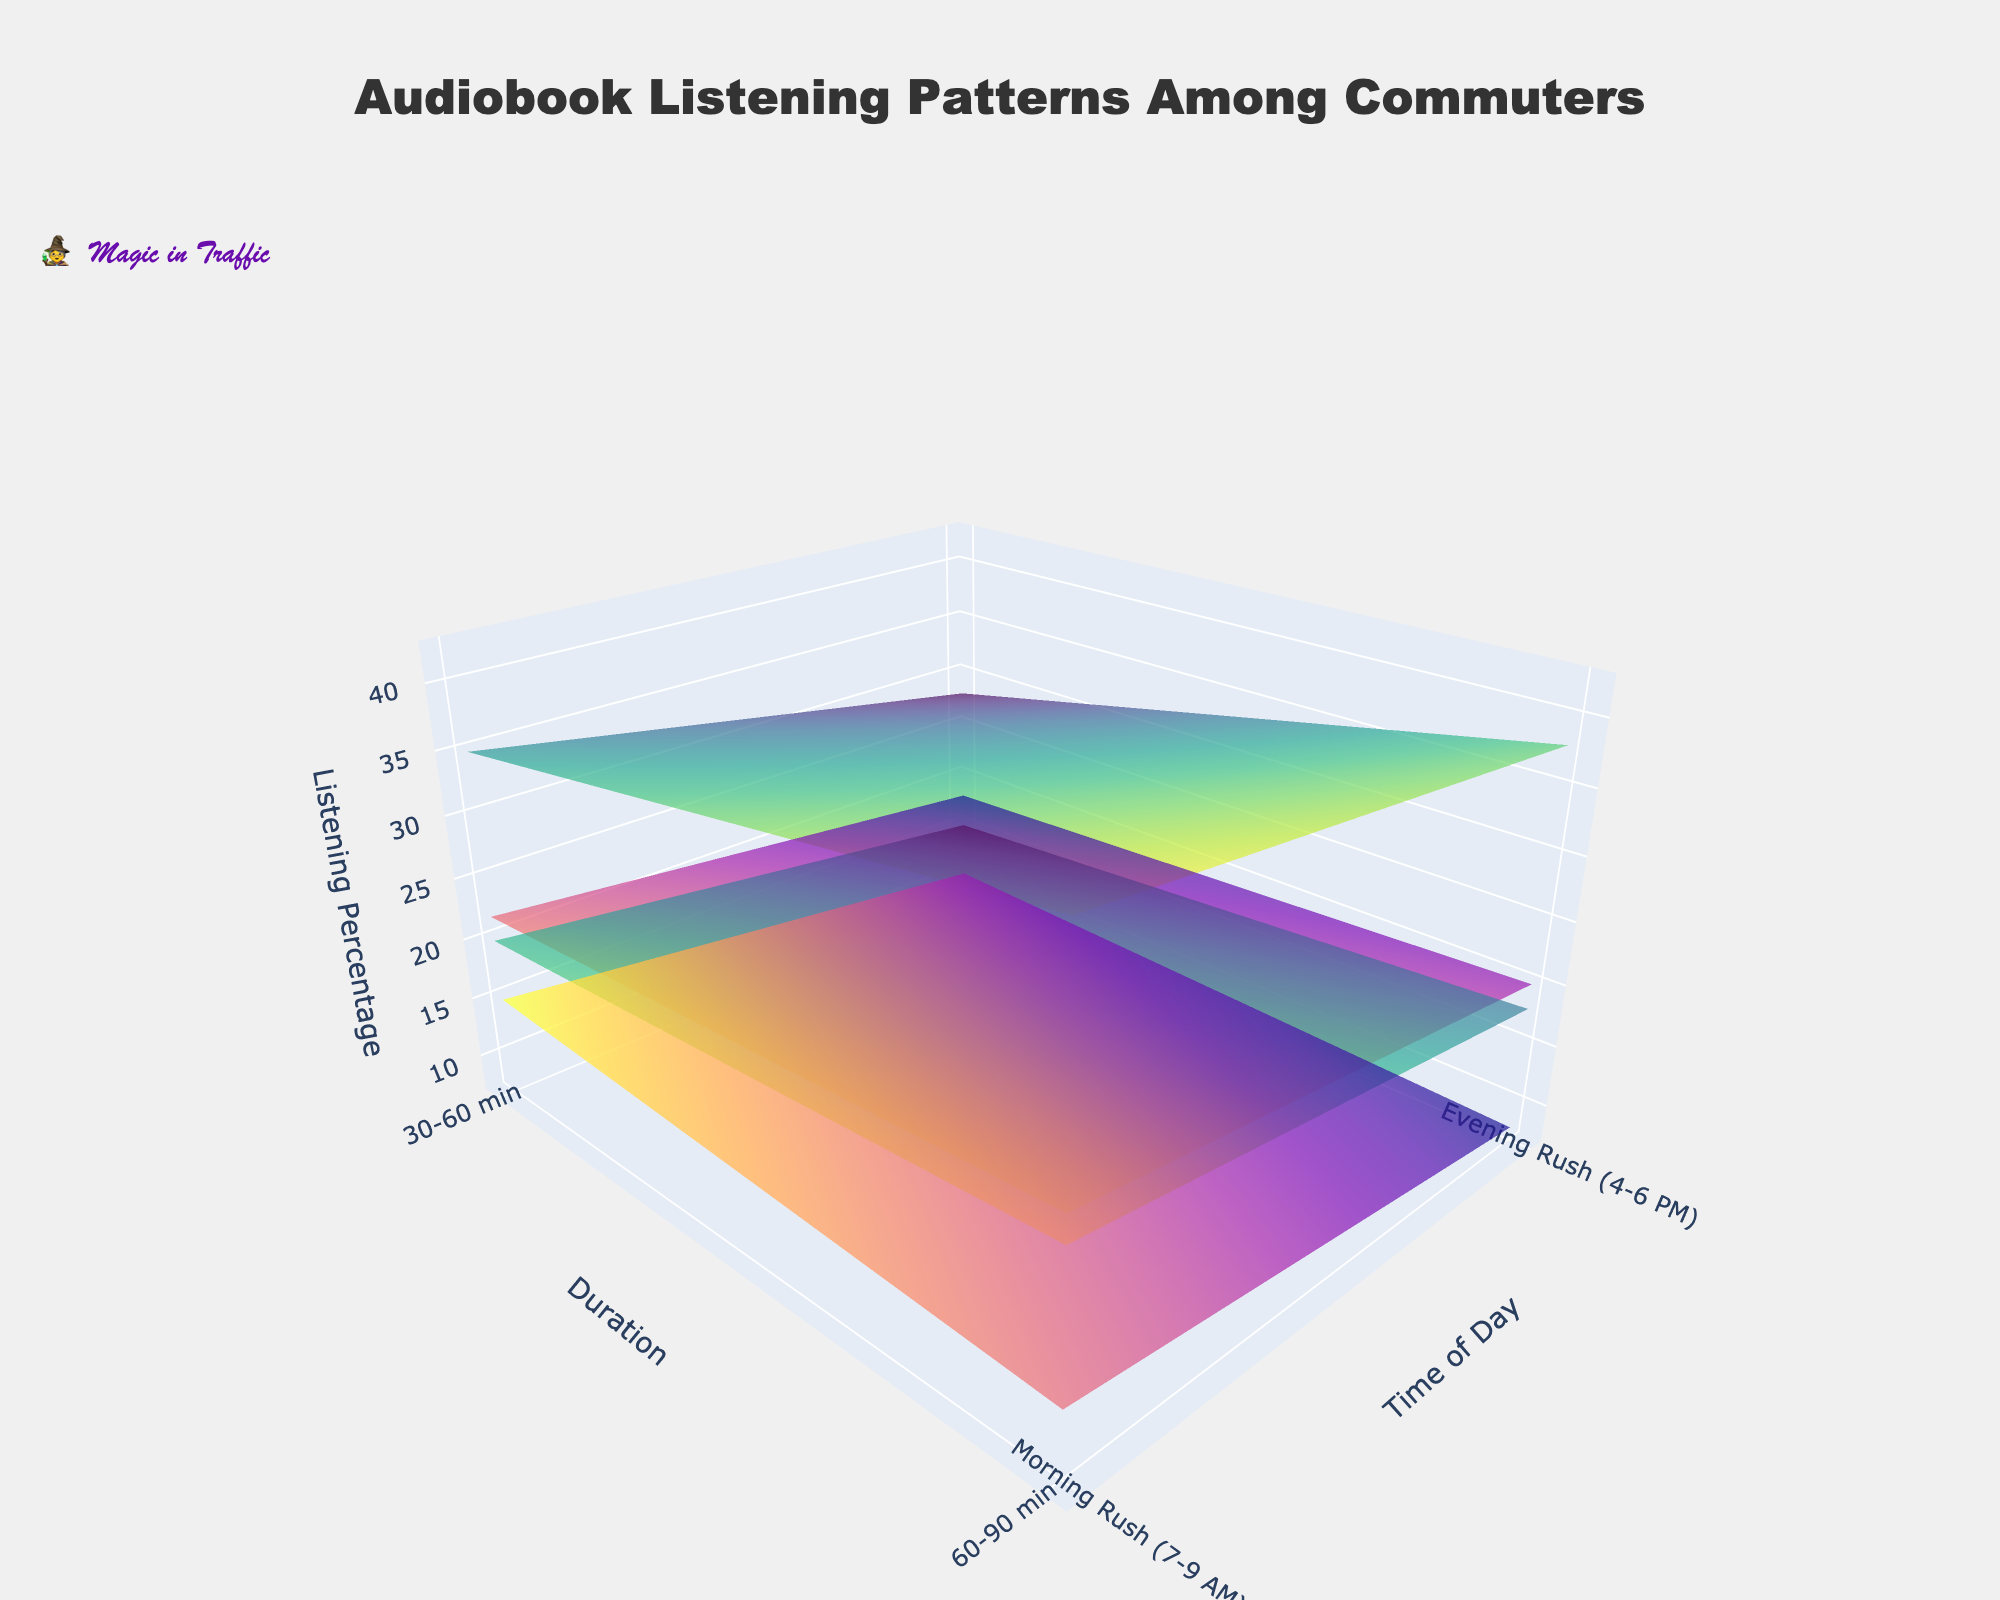what is the overall pattern of audiobook listening during the morning and evening rush hours? The plot shows two distinct peaks, one for the morning rush (7-9 AM) and one for the evening rush (4-6 PM). Listening percentages vary between these times, with the evening rush generally showing higher listening percentages across most genres and durations.
Answer: Evening rush generally higher which genre has the highest listening percentage during the morning rush for 30-60 minutes? Look at the peak values for the morning rush (7-9 AM) within the 30-60 minute duration across different genres. Fantasy genre shows the highest listening percentage at 35%.
Answer: Fantasy which genre has the lowest listening percentage during the evening rush for 60-90 minutes? Look at the peak values for the evening rush (4-6 PM) within the 60-90 minute duration across different genres. Non-Fiction genre shows the lowest listening percentage at 8%.
Answer: Non-Fiction how does the listening percentage for Sci-Fi during the morning rush compare between 30-60 minutes and 60-90 minutes? For Sci-Fi, the morning rush listening percentage for 30-60 minutes is 22%, while for 60-90 minutes it is 18%. The listening percentage decreases as the duration increases. Calculate the difference: 22% - 18% = 4%.
Answer: 4% decrease which genre shows the largest increase in listening percentage from the morning to evening rush for the 60-90 minute duration? Compare the percentage difference between morning and evening rush for each genre within the 60-90 minute duration. Fantasy increases from 28% to 38%, which is a 10% increase. Check other genres: Sci-Fi (18% to 20%, 2% increase), Mystery (15% to 18%, 3% increase), Non-Fiction (10% to 8%, 2% decrease). The largest increase of 10% occurs for Fantasy.
Answer: Fantasy, 10% how does the listening percentage for Fantasy during evening rush compare between 30-60 minutes and 60-90 minutes? For Fantasy, the evening rush listening percentage for 30-60 minutes is 42%, and for 60-90 minutes, it is 38%. The listening percentage decreases as the duration increases. Calculate the difference: 42% - 38% = 4%.
Answer: 4% decrease for which times of the day is audiobook listening for Non-Fiction at its peak? Examine the Non-Fiction data points during morning and evening rush hours. The peak listening percentage occurs during the morning rush (7-9 AM) at 15%.
Answer: Morning rush (7-9 AM) what is the overall trend in listening percentage across different genres for the 30-60 minute duration during the morning rush? Check the 30-60 minute duration during the morning rush for all genres. Fantasy is the highest at 35%, followed by Sci-Fi at 22%, Mystery at 20%, and Non-Fiction at 15%. The ranking is: Fantasy > Sci-Fi > Mystery > Non-Fiction.
Answer: Fantasy > Sci-Fi > Mystery > Non-Fiction 